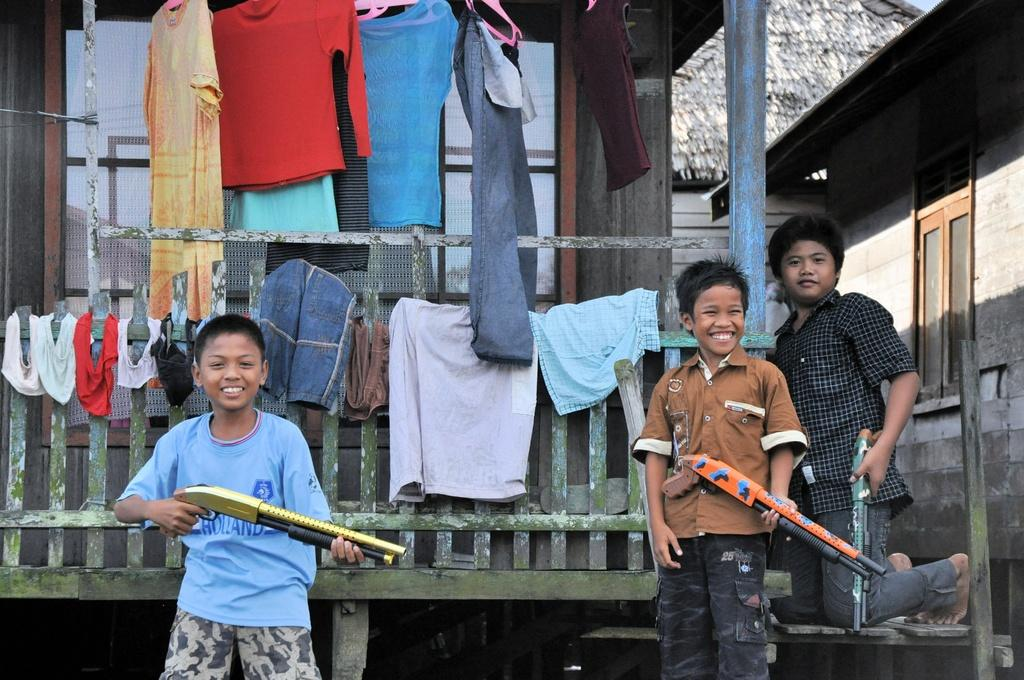How many people are in the image? There are three persons in the image. What are the persons holding in the image? The persons are holding toy guns. What else can be seen in the image besides the people and their toy guns? There are clothes visible in the image. What can be seen in the background of the image? There are three buildings in the background of the image. Is there any rain visible in the image? There is no rain visible in the image. On which side of the image are the buildings located? The provided facts do not specify the side of the image where the buildings are located. 